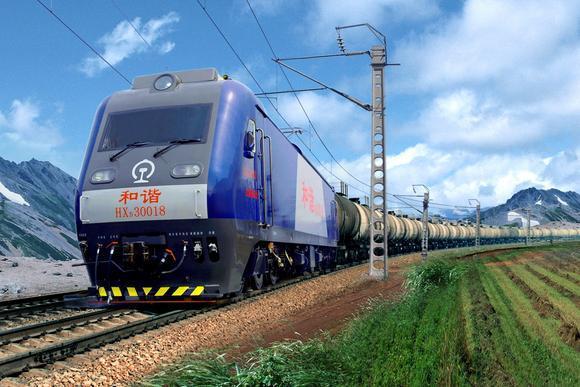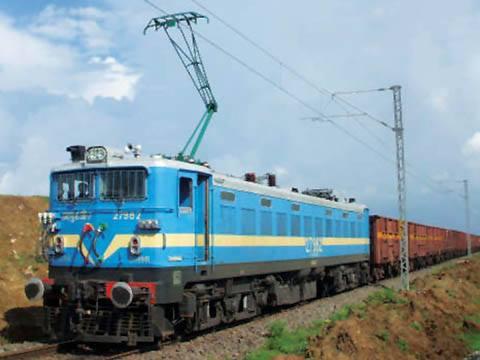The first image is the image on the left, the second image is the image on the right. For the images displayed, is the sentence "The images show blue trains heading leftward." factually correct? Answer yes or no. Yes. The first image is the image on the left, the second image is the image on the right. Evaluate the accuracy of this statement regarding the images: "In the leftmost image the train is blue with red chinese lettering.". Is it true? Answer yes or no. Yes. 